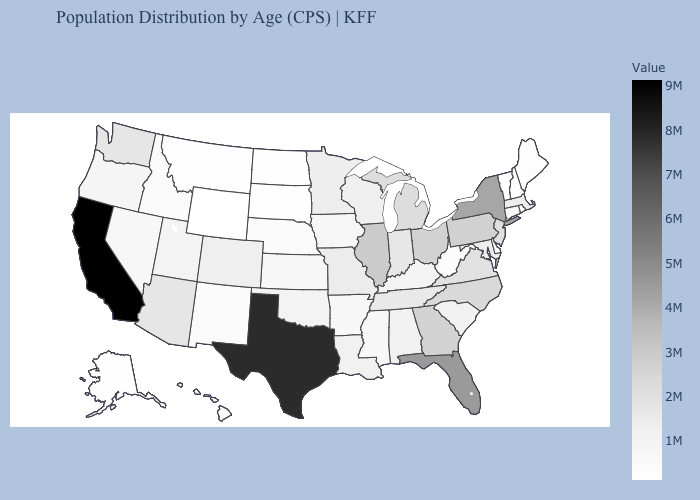Is the legend a continuous bar?
Write a very short answer. Yes. Does the map have missing data?
Write a very short answer. No. Which states have the lowest value in the Northeast?
Give a very brief answer. Vermont. Does Washington have a lower value than Alaska?
Quick response, please. No. Does Florida have a lower value than Maine?
Short answer required. No. Is the legend a continuous bar?
Concise answer only. Yes. 